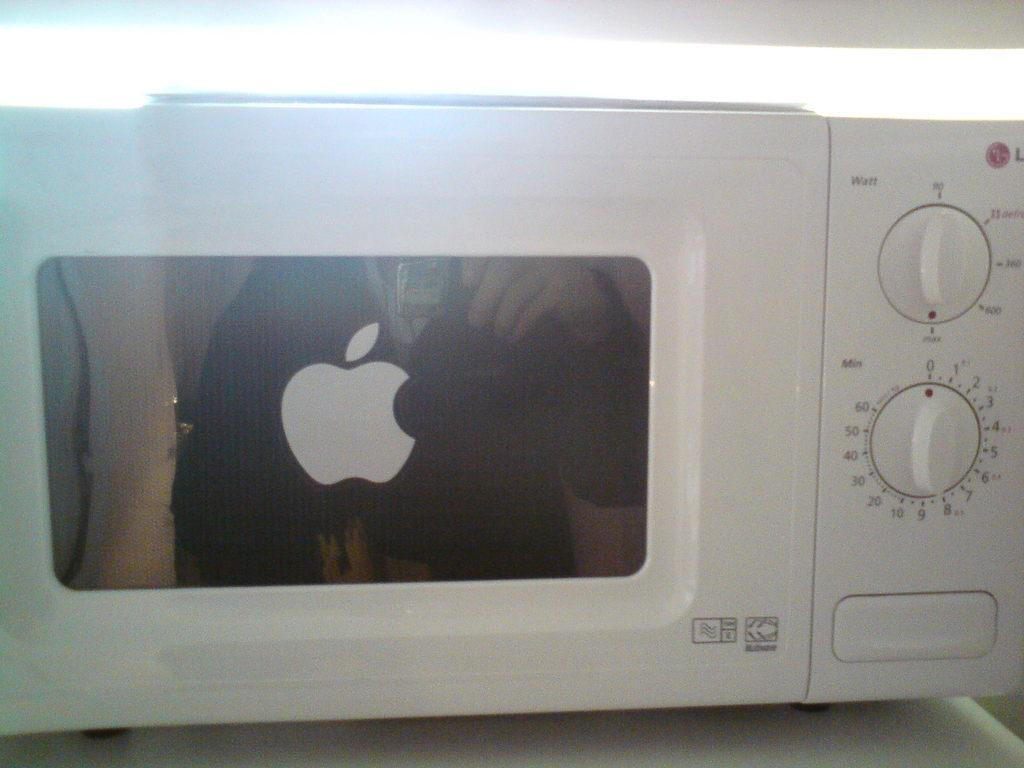Provide a one-sentence caption for the provided image. A white microwave oven with an Apple logo sticker on the door. 